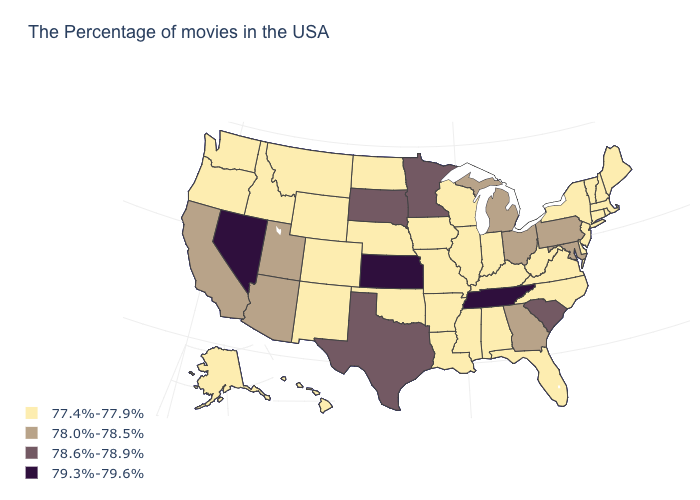What is the highest value in states that border Pennsylvania?
Write a very short answer. 78.0%-78.5%. What is the value of Maine?
Give a very brief answer. 77.4%-77.9%. What is the value of California?
Give a very brief answer. 78.0%-78.5%. Does Kentucky have the same value as Texas?
Concise answer only. No. How many symbols are there in the legend?
Write a very short answer. 4. What is the highest value in the Northeast ?
Be succinct. 78.0%-78.5%. Does Kansas have the highest value in the USA?
Answer briefly. Yes. Which states have the highest value in the USA?
Concise answer only. Tennessee, Kansas, Nevada. Does the map have missing data?
Write a very short answer. No. Does South Carolina have a lower value than Rhode Island?
Answer briefly. No. Does Tennessee have the highest value in the USA?
Concise answer only. Yes. How many symbols are there in the legend?
Concise answer only. 4. What is the value of Rhode Island?
Write a very short answer. 77.4%-77.9%. Does Maryland have a higher value than Nebraska?
Keep it brief. Yes. 